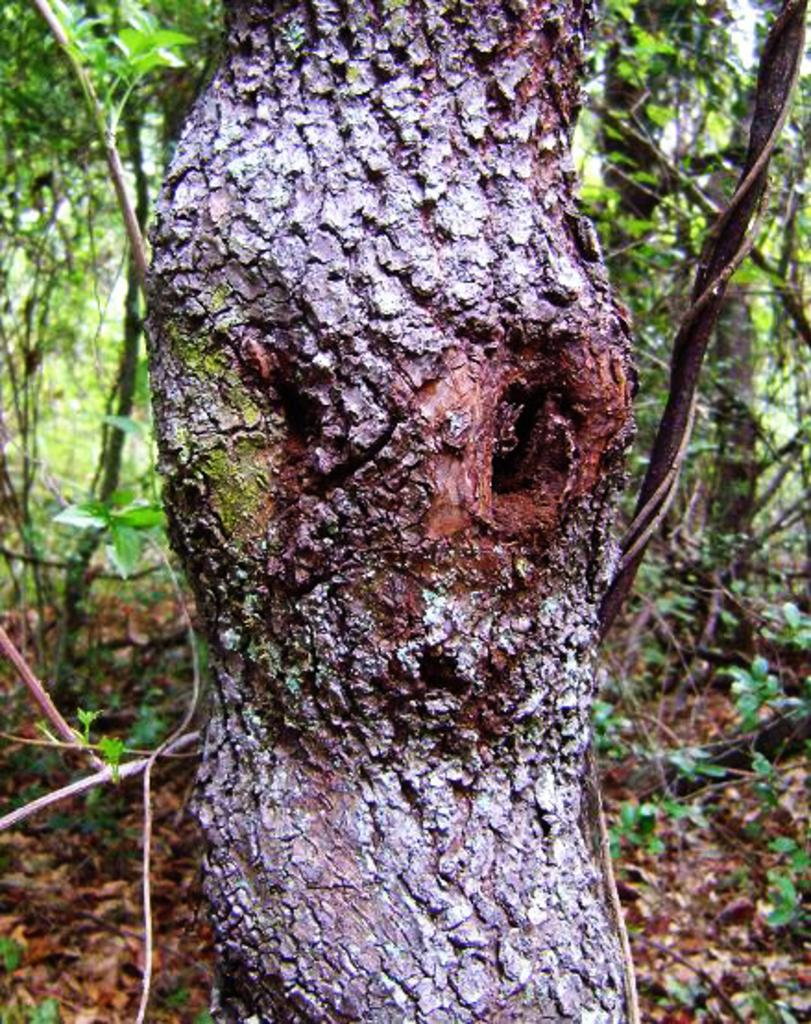What is the main subject of the image? There is a branch of a tree in the image. What can be seen in the background of the image? There are many trees visible in the background of the image. What is the color of the trees in the background? The trees in the background are green. How many tomatoes can be seen hanging from the tree branch in the image? There are no tomatoes present in the image; it features a branch of a tree with no visible fruits. What type of board is being used to support the tree branch in the image? There is no board present in the image; the tree branch is not supported by any visible structure. 